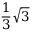Convert formula to latex. <formula><loc_0><loc_0><loc_500><loc_500>{ \frac { 1 } { 3 } } { \sqrt { 3 } }</formula> 